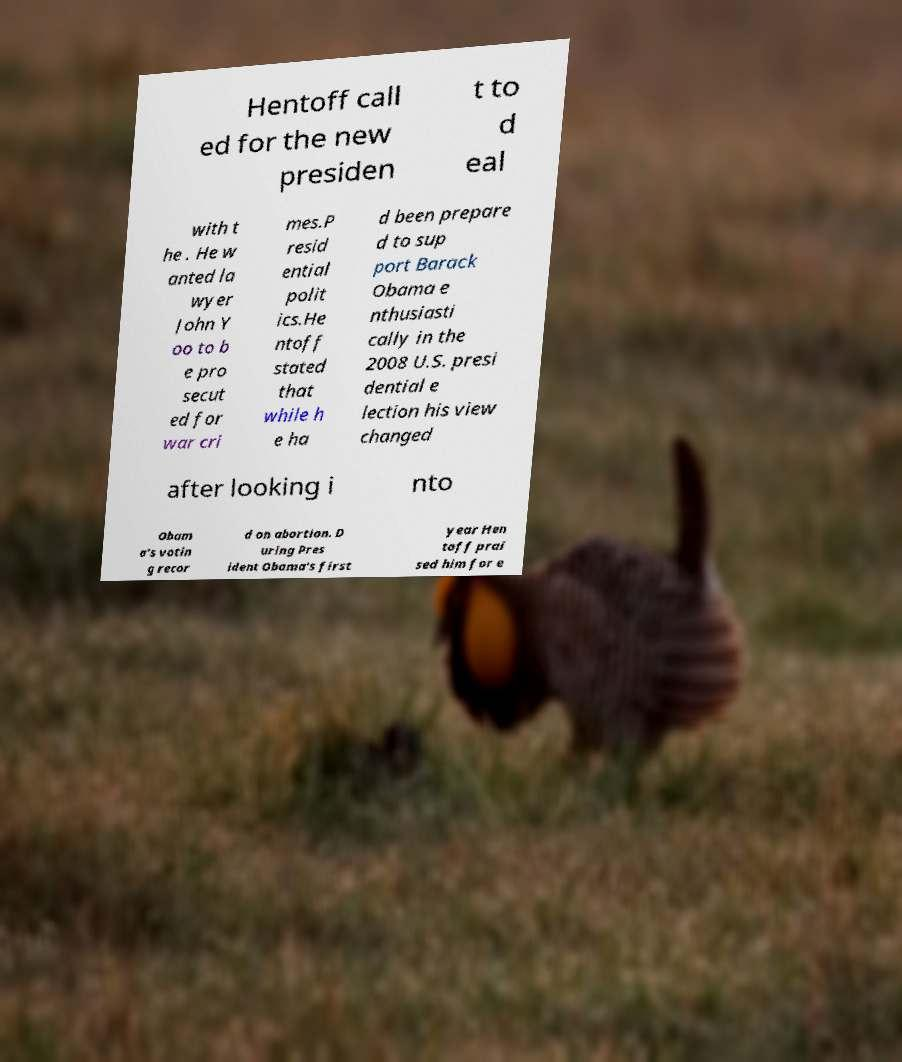Please identify and transcribe the text found in this image. Hentoff call ed for the new presiden t to d eal with t he . He w anted la wyer John Y oo to b e pro secut ed for war cri mes.P resid ential polit ics.He ntoff stated that while h e ha d been prepare d to sup port Barack Obama e nthusiasti cally in the 2008 U.S. presi dential e lection his view changed after looking i nto Obam a's votin g recor d on abortion. D uring Pres ident Obama's first year Hen toff prai sed him for e 